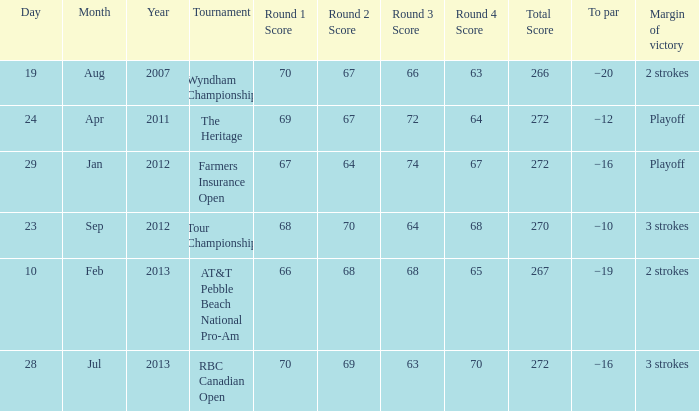What tournament was on Jan 29, 2012? Farmers Insurance Open. 